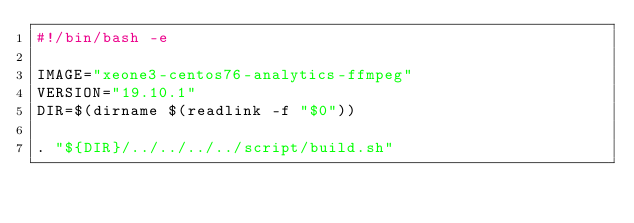Convert code to text. <code><loc_0><loc_0><loc_500><loc_500><_Bash_>#!/bin/bash -e

IMAGE="xeone3-centos76-analytics-ffmpeg"
VERSION="19.10.1"
DIR=$(dirname $(readlink -f "$0"))

. "${DIR}/../../../../script/build.sh"
</code> 